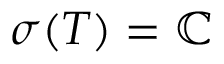Convert formula to latex. <formula><loc_0><loc_0><loc_500><loc_500>\sigma ( T ) = \mathbb { C }</formula> 